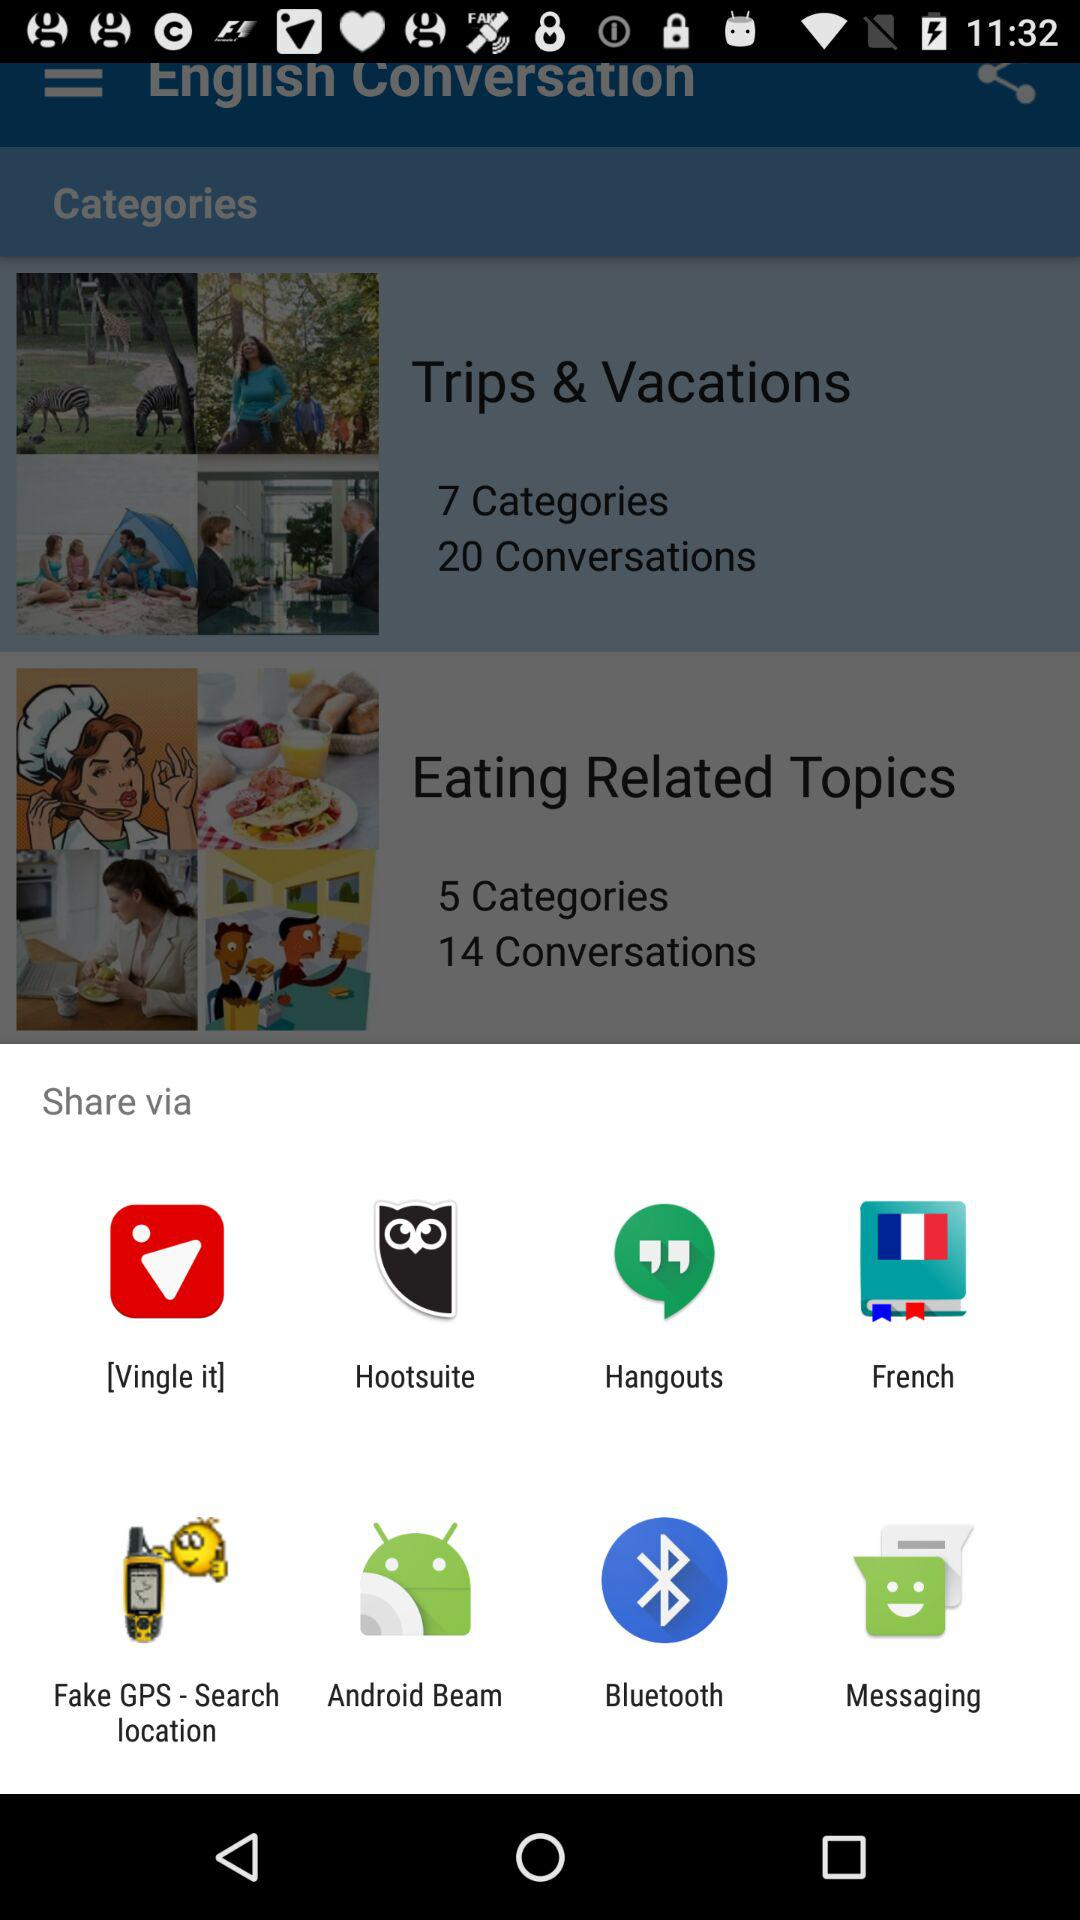How many conversations are there in "Eating Related Topics"? There are 14 conversations. 